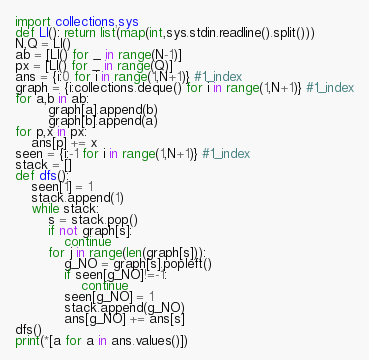<code> <loc_0><loc_0><loc_500><loc_500><_Python_>import collections,sys
def LI(): return list(map(int,sys.stdin.readline().split()))
N,Q = LI()
ab = [LI() for _ in range(N-1)]
px = [LI() for _ in range(Q)]
ans = {i:0 for i in range(1,N+1)} #1_index
graph = {i:collections.deque() for i in range(1,N+1)} #1_index
for a,b in ab:
        graph[a].append(b)
        graph[b].append(a)
for p,x in px:
    ans[p] += x
seen = {i:-1 for i in range(1,N+1)} #1_index
stack = []
def dfs():
    seen[1] = 1
    stack.append(1)
    while stack:
        s = stack.pop()
        if not graph[s]:
            continue
        for j in range(len(graph[s])):
            g_NO = graph[s].popleft()
            if seen[g_NO]!=-1:
                continue
            seen[g_NO] = 1
            stack.append(g_NO)
            ans[g_NO] += ans[s]
dfs()
print(*[a for a in ans.values()])
</code> 